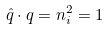Convert formula to latex. <formula><loc_0><loc_0><loc_500><loc_500>\hat { q } \cdot q = n _ { i } ^ { 2 } = 1</formula> 